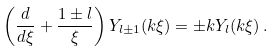Convert formula to latex. <formula><loc_0><loc_0><loc_500><loc_500>\left ( \frac { d } { d \xi } + \frac { 1 \pm l } { \xi } \right ) Y _ { l \pm 1 } ( k \xi ) = \pm k Y _ { l } ( k \xi ) \, .</formula> 